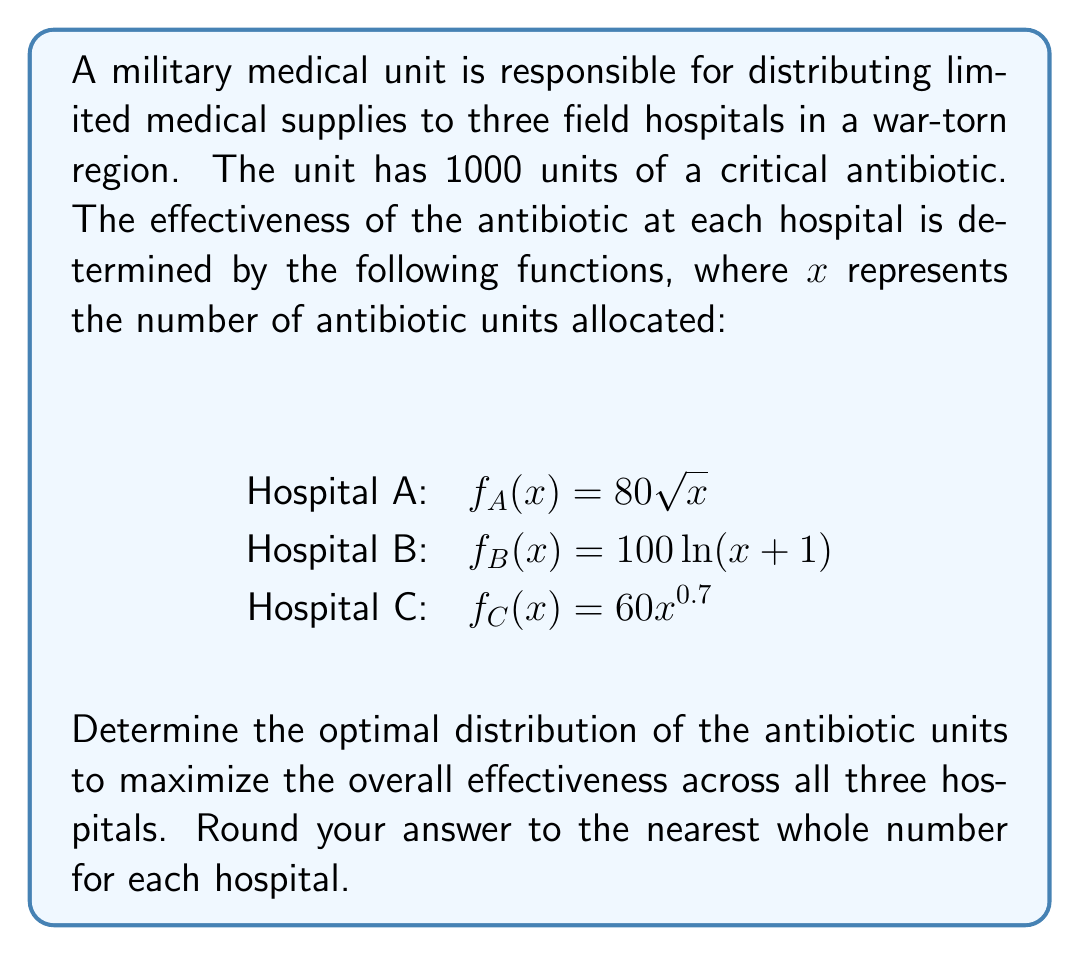Show me your answer to this math problem. To solve this optimization problem, we'll use the method of Lagrange multipliers:

1) Let $x$, $y$, and $z$ be the amounts allocated to Hospitals A, B, and C respectively.

2) Our objective function is:
   $$F(x,y,z) = 80\sqrt{x} + 100\ln(y+1) + 60z^{0.7}$$

3) The constraint is:
   $$x + y + z = 1000$$

4) Form the Lagrangian:
   $$L(x,y,z,\lambda) = 80\sqrt{x} + 100\ln(y+1) + 60z^{0.7} - \lambda(x + y + z - 1000)$$

5) Set partial derivatives to zero:
   $$\frac{\partial L}{\partial x} = \frac{40}{\sqrt{x}} - \lambda = 0$$
   $$\frac{\partial L}{\partial y} = \frac{100}{y+1} - \lambda = 0$$
   $$\frac{\partial L}{\partial z} = 42z^{-0.3} - \lambda = 0$$
   $$\frac{\partial L}{\partial \lambda} = x + y + z - 1000 = 0$$

6) From these equations:
   $$x = \frac{1600}{\lambda^2}$$
   $$y = \frac{100}{\lambda} - 1$$
   $$z = (\frac{42}{\lambda})^{\frac{10}{3}}$$

7) Substitute these into the constraint equation and solve numerically for $\lambda$:
   $$\frac{1600}{\lambda^2} + \frac{100}{\lambda} - 1 + (\frac{42}{\lambda})^{\frac{10}{3}} = 1000$$

8) Using numerical methods, we find $\lambda \approx 0.2857$

9) Substitute this value back into the equations for $x$, $y$, and $z$:
   $$x \approx 196$$
   $$y \approx 349$$
   $$z \approx 455$$

10) Rounding to the nearest whole number:
    Hospital A: 196 units
    Hospital B: 349 units
    Hospital C: 455 units
Answer: The optimal distribution of antibiotic units:
Hospital A: 196 units
Hospital B: 349 units
Hospital C: 455 units 